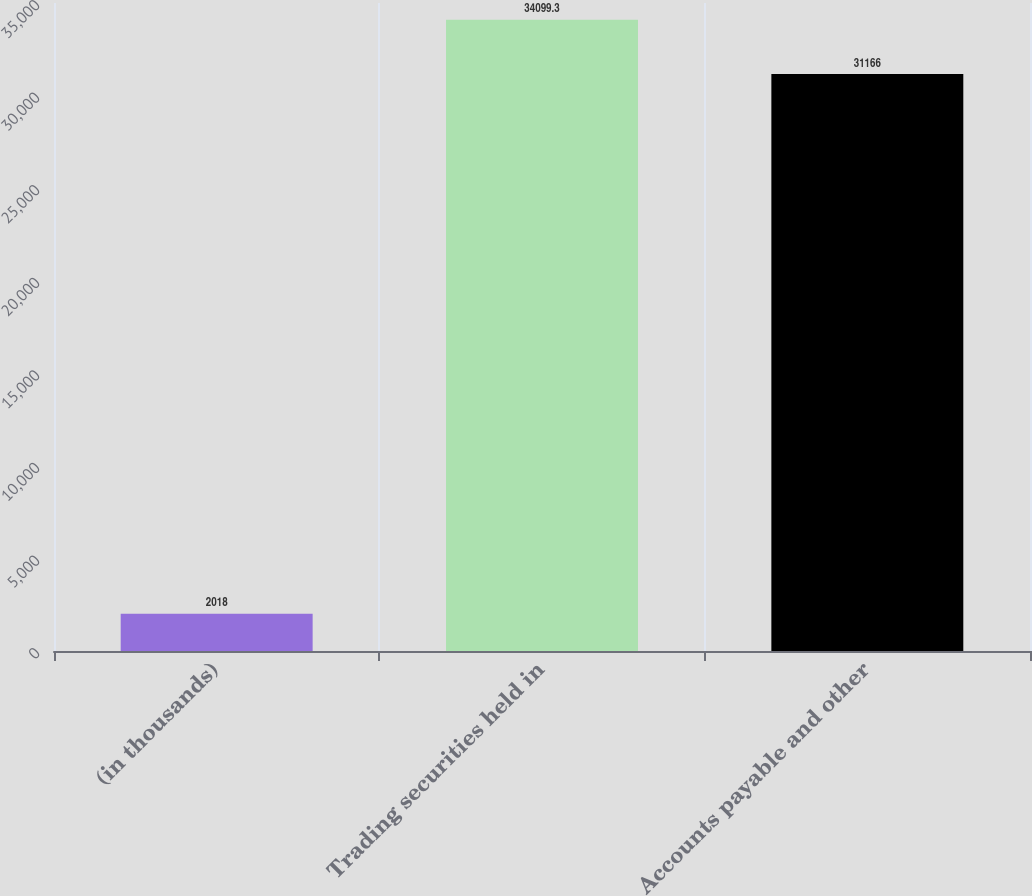Convert chart. <chart><loc_0><loc_0><loc_500><loc_500><bar_chart><fcel>(in thousands)<fcel>Trading securities held in<fcel>Accounts payable and other<nl><fcel>2018<fcel>34099.3<fcel>31166<nl></chart> 